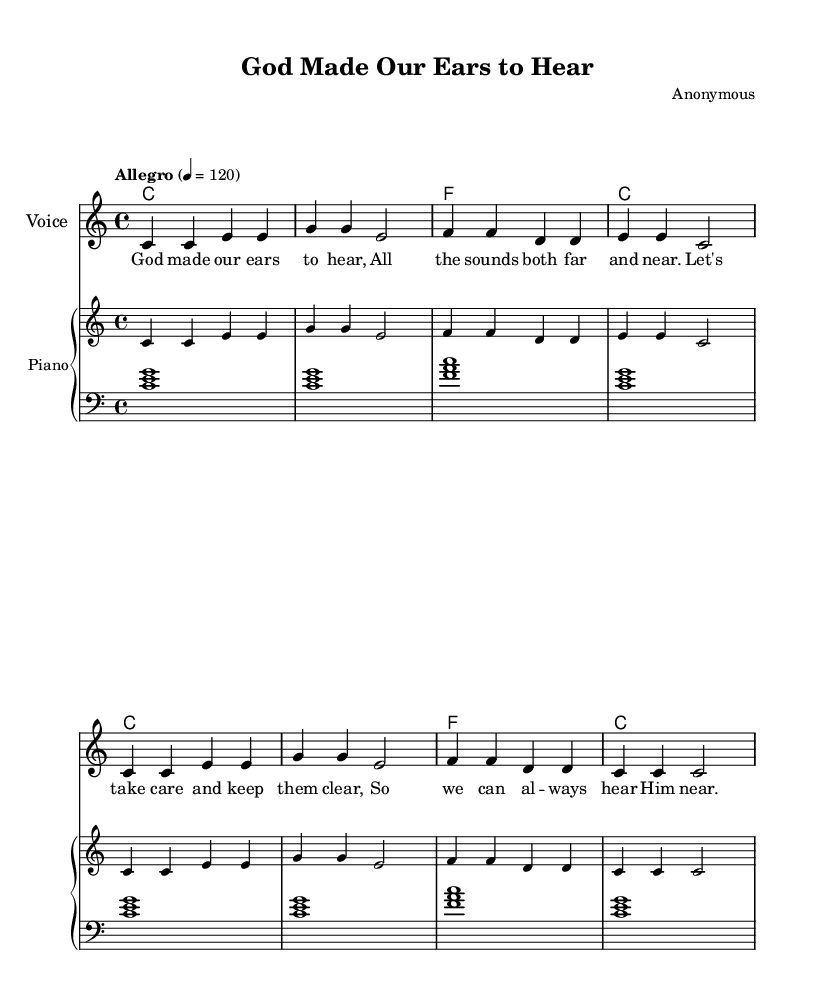What is the key signature of this music? The key signature is C major, which has no sharps or flats.
Answer: C major What is the time signature of this piece? The time signature is indicated by the notation and shows that there are four beats per measure.
Answer: 4/4 What is the tempo marking of this song? The tempo marking indicates "Allegro" with a beats per minute (BPM) of 120.
Answer: Allegro, 120 How many measures are in the melody? Counting the measures in the melody section, there are a total of eight measures present.
Answer: 8 What lyrical theme is presented in the song? The lyrics emphasize the importance of caring for our hearing and recognizing God's presence through sound.
Answer: Caring for hearing How many different chords are used throughout the piece? The chord progression in the song has four distinct chords repeated in various measures: C and F.
Answer: 2 (C, F) What is the primary instrument for the melody? The score indicates that the melody is designated for the voice, as specified in the instrument name.
Answer: Voice 